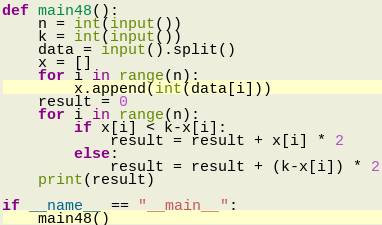<code> <loc_0><loc_0><loc_500><loc_500><_Python_>def main48():
    n = int(input())
    k = int(input())
    data = input().split()
    x = []
    for i in range(n):
        x.append(int(data[i]))
    result = 0
    for i in range(n):
        if x[i] < k-x[i]:
            result = result + x[i] * 2
        else:
            result = result + (k-x[i]) * 2
    print(result)

if __name__ == "__main__":
    main48()</code> 